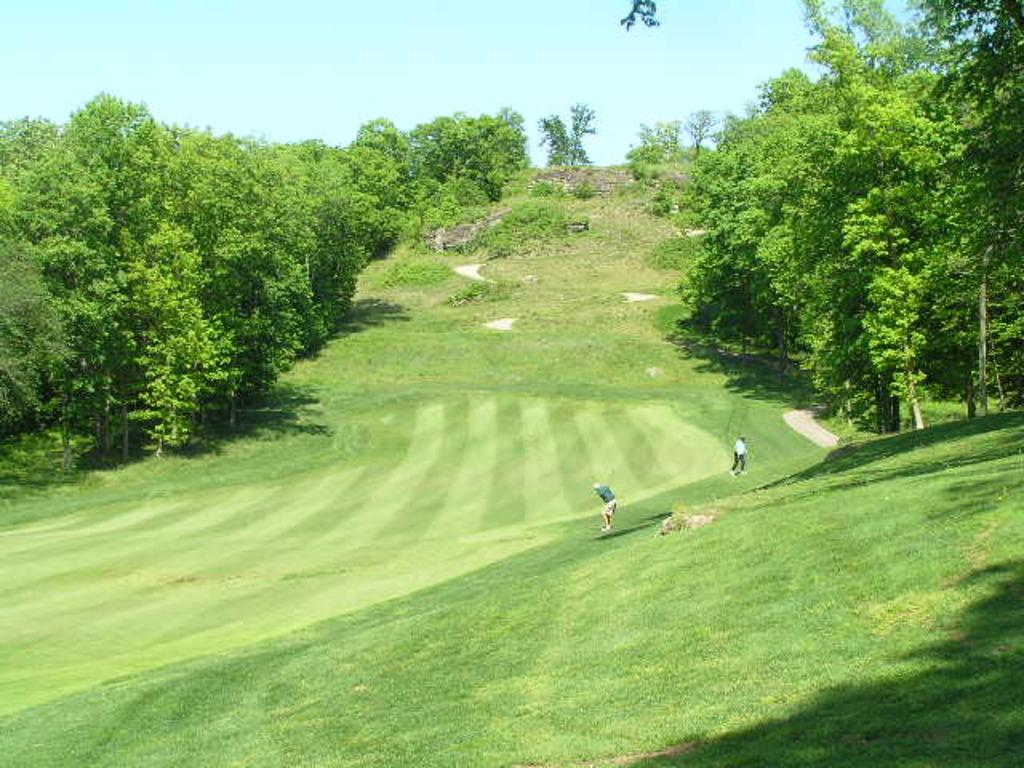What is visible at the top of the image? The sky is visible at the top of the image. What type of vegetation can be seen in the image? There are trees, plants, and grass in the image. How many men are present in the image? There are two men in the image, one standing and one walking. How many girls are present in the image? There are no girls present in the image; it features two men. What type of work is the man doing in the image? The provided facts do not mention any work being done by the man in the image. 